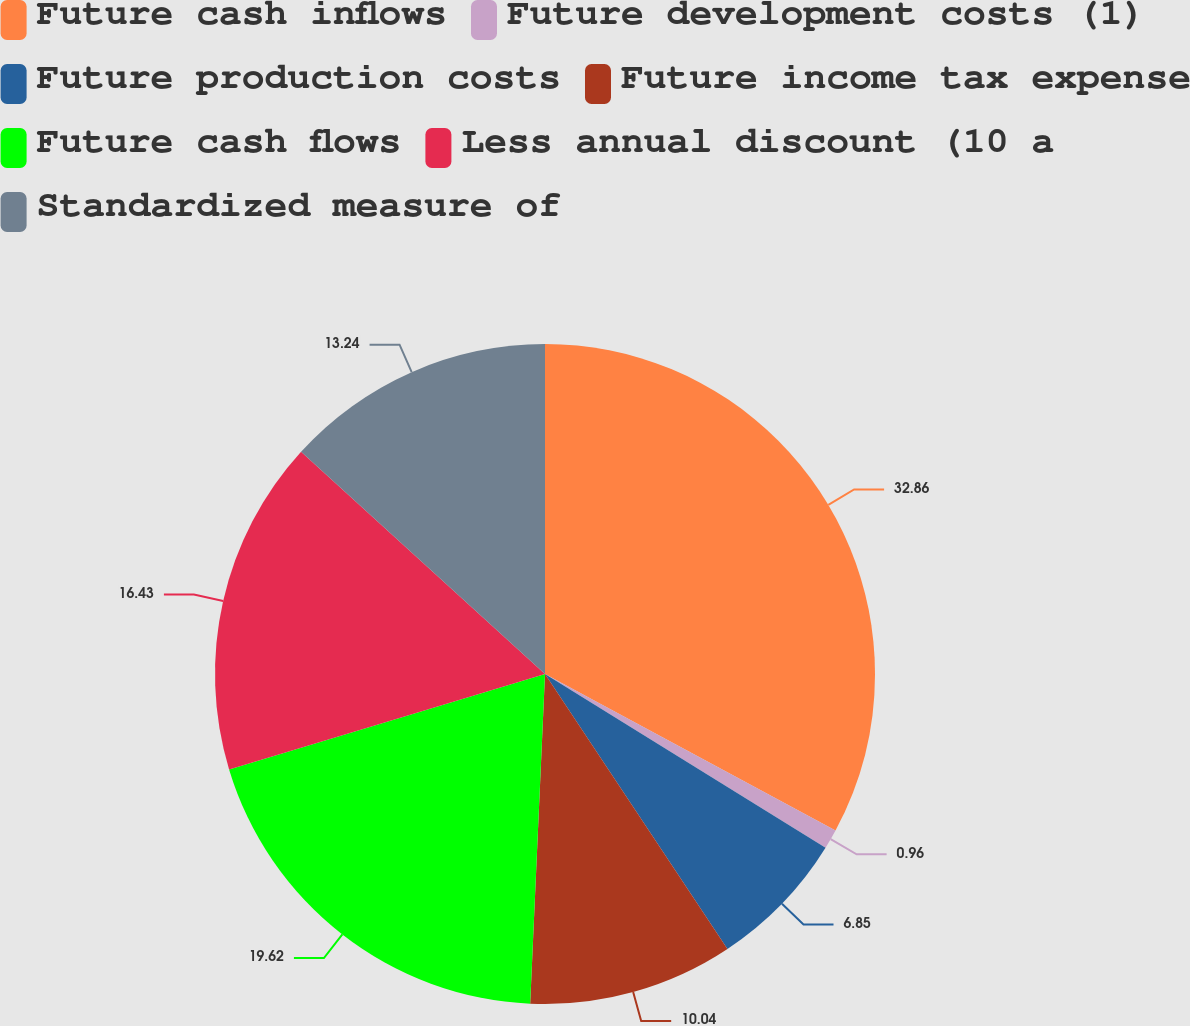Convert chart to OTSL. <chart><loc_0><loc_0><loc_500><loc_500><pie_chart><fcel>Future cash inflows<fcel>Future development costs (1)<fcel>Future production costs<fcel>Future income tax expense<fcel>Future cash flows<fcel>Less annual discount (10 a<fcel>Standardized measure of<nl><fcel>32.87%<fcel>0.96%<fcel>6.85%<fcel>10.04%<fcel>19.62%<fcel>16.43%<fcel>13.24%<nl></chart> 